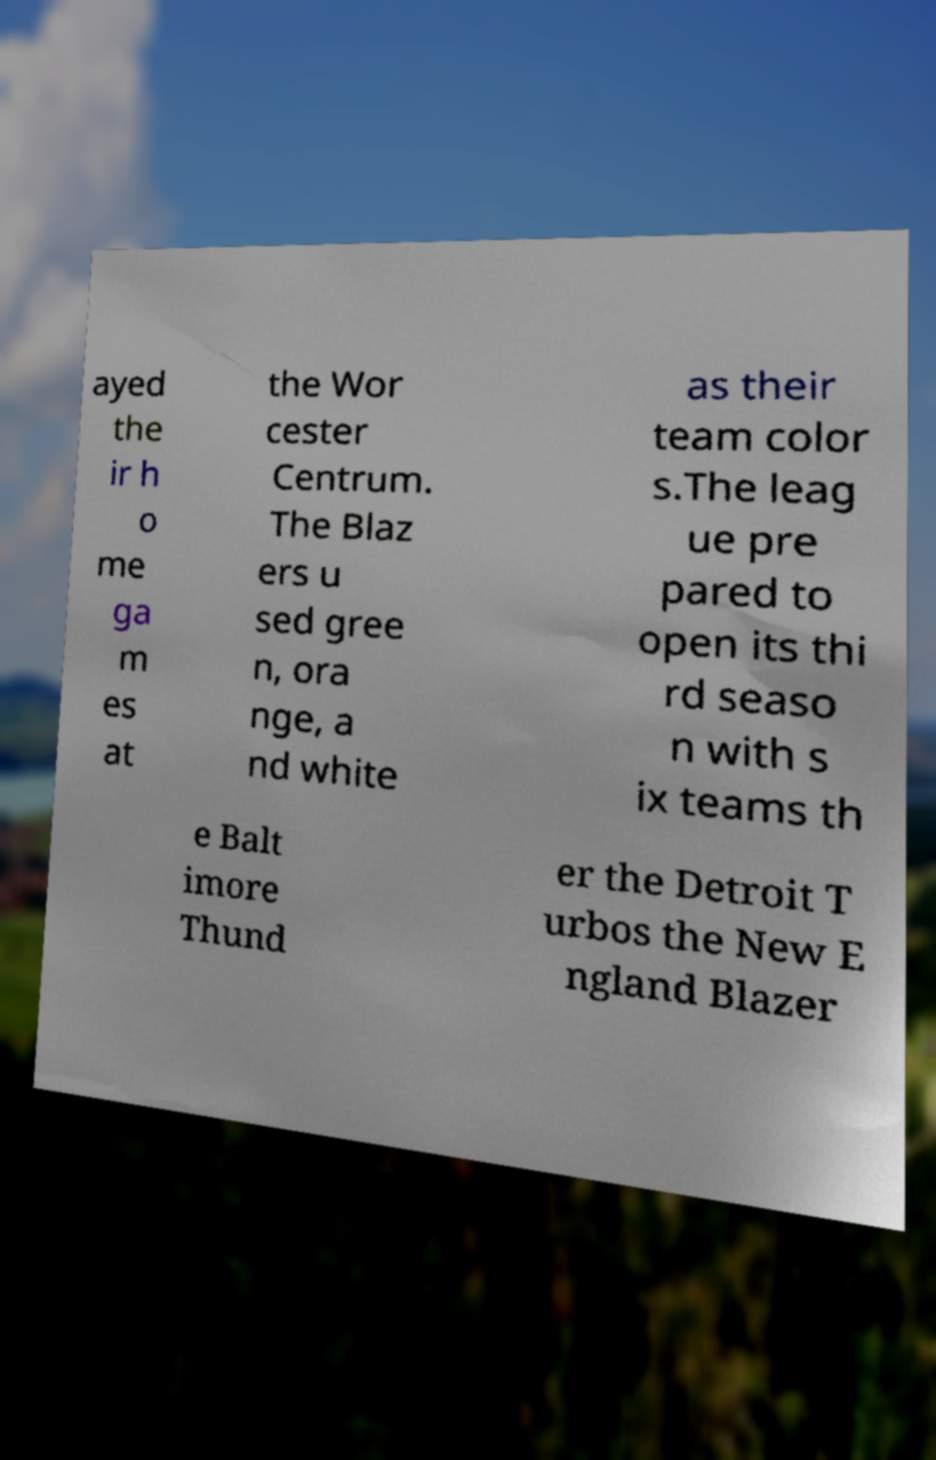Please identify and transcribe the text found in this image. ayed the ir h o me ga m es at the Wor cester Centrum. The Blaz ers u sed gree n, ora nge, a nd white as their team color s.The leag ue pre pared to open its thi rd seaso n with s ix teams th e Balt imore Thund er the Detroit T urbos the New E ngland Blazer 